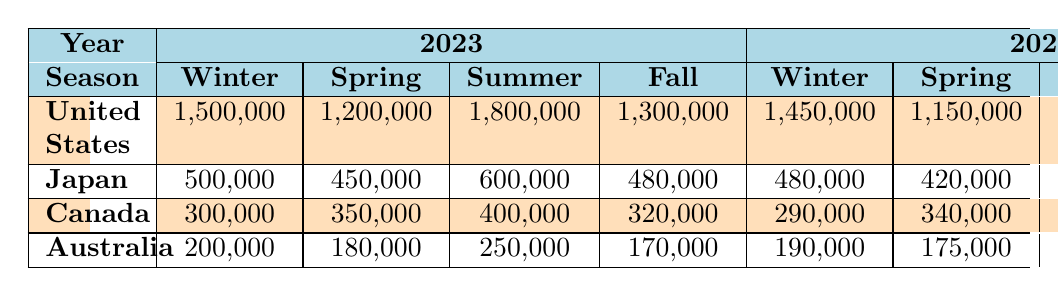What's the total number of flight arrivals from the United States in Summer 2023? The table shows that in Summer 2023, the flight arrivals from the United States were 1,800,000. There are no additional numbers to sum or compare, so I can directly take this value from the table.
Answer: 1,800,000 How many more flight arrivals from Japan were there in Summer 2023 compared to Spring 2022? In Summer 2023, the flight arrivals from Japan were 600,000, and in Spring 2022, they were 420,000. To find the difference, I subtract the Spring 2022 total from the Summer 2023 total: 600,000 - 420,000 = 180,000.
Answer: 180,000 Did flight arrivals from Canada increase or decrease from Winter 2022 to Winter 2023? In Winter 2022, the flight arrivals from Canada were 290,000. In Winter 2023, they were 300,000. Since 300,000 is greater than 290,000, it indicates an increase.
Answer: Yes What's the average number of flight arrivals from Australia across all seasons in 2023? I look at the flight arrivals from Australia in 2023 across all seasons: Winter (200,000), Spring (180,000), Summer (250,000), and Fall (170,000). To find the average, I sum these values: 200,000 + 180,000 + 250,000 + 170,000 = 800,000. Then I divide by the number of seasons (4): 800,000 / 4 = 200,000.
Answer: 200,000 Which country had the highest number of flight arrivals in Fall 2022? The table shows that in Fall 2022, the flight arrivals were: United States (1,250,000), Japan (460,000), Canada (310,000), and Australia (165,000). The United States had the highest number of arrivals, which is evident by comparing these four values.
Answer: United States What was the total number of flight arrivals from all countries in Spring 2022? I sum the flight arrivals from each country in Spring 2022: United States (1,150,000) + Japan (420,000) + Canada (340,000) + Australia (175,000) = 2,085,000. This gives the total for that season.
Answer: 2,085,000 Was there a greater number of flight arrivals from Japan in Winter or Fall 2023? For Winter 2023, Japan had 500,000 arrivals. For Fall 2023, it had 480,000. Since 500,000 is greater than 480,000, there were more arrivals in Winter.
Answer: Winter 2023 What is the total number of flight arrivals from Canada across both years in Summer? In Summer 2023, the arrivals from Canada were 400,000, and in Summer 2022, they were 390,000. To get the total, I add these two numbers: 400,000 + 390,000 = 790,000, indicating the sum across both years for that season.
Answer: 790,000 